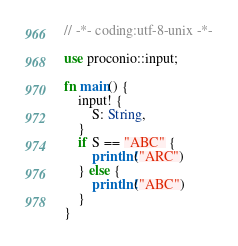Convert code to text. <code><loc_0><loc_0><loc_500><loc_500><_Rust_>// -*- coding:utf-8-unix -*-

use proconio::input;

fn main() {
    input! {
        S: String,
    }
    if S == "ABC" {
        println!("ARC")
    } else {
        println!("ABC")
    }
}
</code> 